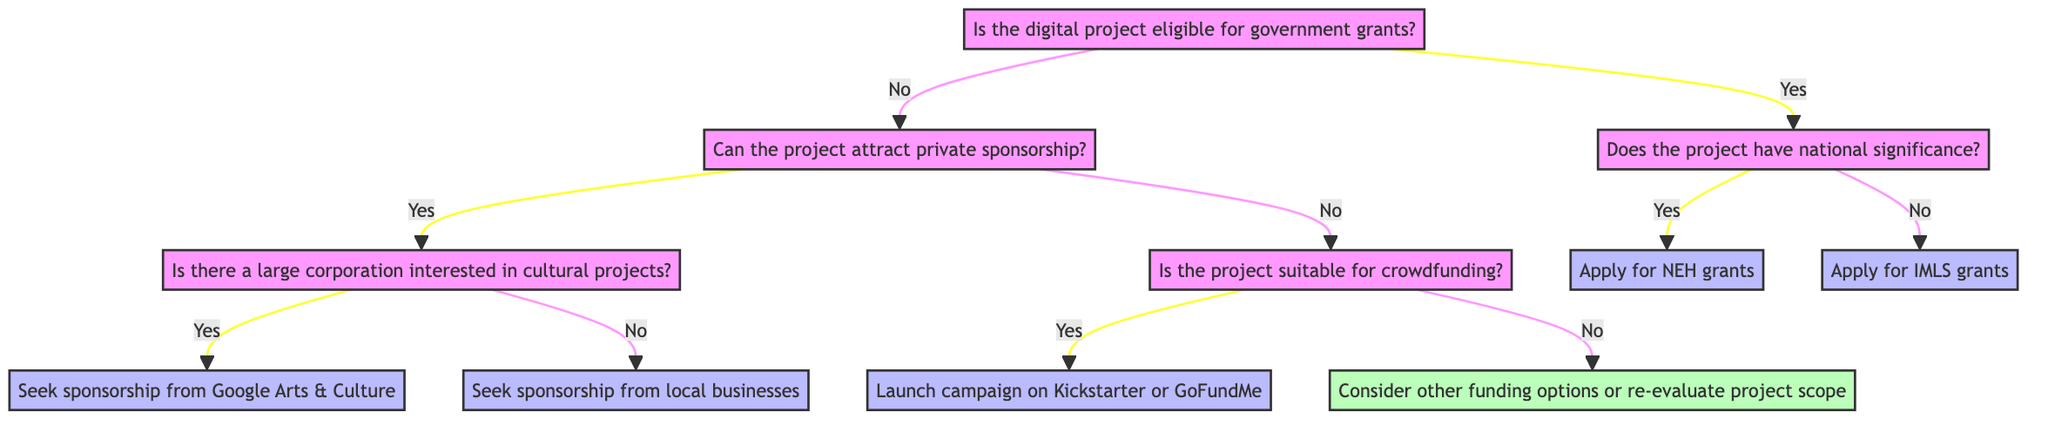What is the first question in the diagram? The first question in the diagram is located at the top and asks whether the digital project is eligible for government grants.
Answer: Is the digital project eligible for government grants? How many actions are listed in the diagram? To find the number of actions, I will count each unique action node present in the decision tree: 5 unique actions can be identified (apply for NEH grants, apply for IMLS grants, seek sponsorship from Google Arts & Culture, seek sponsorship from local businesses, launch campaign on Kickstarter or GoFundMe, and consider other funding options or re-evaluate project scope).
Answer: 6 What is the action for a project that is not eligible for government grants but can attract private sponsorship? After determining that the project is not eligible for government grants, we check if it can attract private sponsorship. If yes, the next question will determine whether there is a large corporation interested; if the answer is 'no,' the action is to seek sponsorship from local businesses.
Answer: Seek sponsorship from local businesses What must a project do if it can attract private sponsorship but no large corporation is interested? If the project's potential for attracting private sponsorship does not involve a large corporation, the action to be taken is explicitly stated, which is to seek sponsorship from local businesses.
Answer: Seek sponsorship from local businesses What is required if the project is suitable for crowdfunding? In the case that the project qualifies for crowdfunding, there are specific application requirements that must be fulfilled, which are the creation of a compelling campaign story, offering donation incentives, and developing a strategy for progress updates.
Answer: Compelling campaign story, donation incentives, progress update strategy What is the final action suggested if the project is not eligible for government grants and cannot attract private sponsorship nor is suitable for crowdfunding? In this scenario, where a project lacks eligibility for government grants, inability to attract private sponsorship, and is unsuitable for crowdfunding, the diagram suggests considering alternative funding options or re-evaluating the project scope.
Answer: Consider other funding options or re-evaluate project scope 